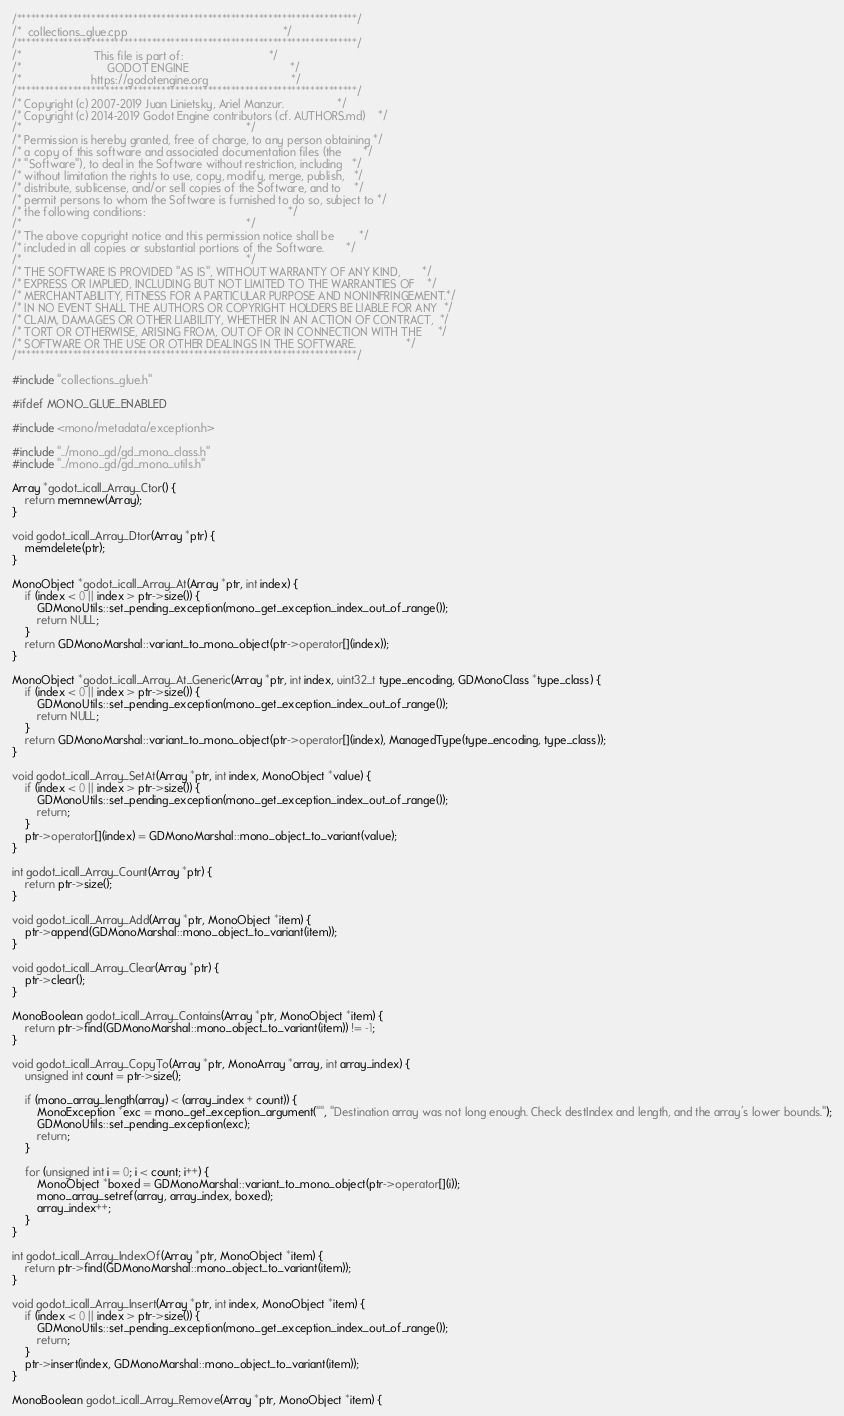Convert code to text. <code><loc_0><loc_0><loc_500><loc_500><_C++_>/*************************************************************************/
/*  collections_glue.cpp                                                 */
/*************************************************************************/
/*                       This file is part of:                           */
/*                           GODOT ENGINE                                */
/*                      https://godotengine.org                          */
/*************************************************************************/
/* Copyright (c) 2007-2019 Juan Linietsky, Ariel Manzur.                 */
/* Copyright (c) 2014-2019 Godot Engine contributors (cf. AUTHORS.md)    */
/*                                                                       */
/* Permission is hereby granted, free of charge, to any person obtaining */
/* a copy of this software and associated documentation files (the       */
/* "Software"), to deal in the Software without restriction, including   */
/* without limitation the rights to use, copy, modify, merge, publish,   */
/* distribute, sublicense, and/or sell copies of the Software, and to    */
/* permit persons to whom the Software is furnished to do so, subject to */
/* the following conditions:                                             */
/*                                                                       */
/* The above copyright notice and this permission notice shall be        */
/* included in all copies or substantial portions of the Software.       */
/*                                                                       */
/* THE SOFTWARE IS PROVIDED "AS IS", WITHOUT WARRANTY OF ANY KIND,       */
/* EXPRESS OR IMPLIED, INCLUDING BUT NOT LIMITED TO THE WARRANTIES OF    */
/* MERCHANTABILITY, FITNESS FOR A PARTICULAR PURPOSE AND NONINFRINGEMENT.*/
/* IN NO EVENT SHALL THE AUTHORS OR COPYRIGHT HOLDERS BE LIABLE FOR ANY  */
/* CLAIM, DAMAGES OR OTHER LIABILITY, WHETHER IN AN ACTION OF CONTRACT,  */
/* TORT OR OTHERWISE, ARISING FROM, OUT OF OR IN CONNECTION WITH THE     */
/* SOFTWARE OR THE USE OR OTHER DEALINGS IN THE SOFTWARE.                */
/*************************************************************************/

#include "collections_glue.h"

#ifdef MONO_GLUE_ENABLED

#include <mono/metadata/exception.h>

#include "../mono_gd/gd_mono_class.h"
#include "../mono_gd/gd_mono_utils.h"

Array *godot_icall_Array_Ctor() {
	return memnew(Array);
}

void godot_icall_Array_Dtor(Array *ptr) {
	memdelete(ptr);
}

MonoObject *godot_icall_Array_At(Array *ptr, int index) {
	if (index < 0 || index > ptr->size()) {
		GDMonoUtils::set_pending_exception(mono_get_exception_index_out_of_range());
		return NULL;
	}
	return GDMonoMarshal::variant_to_mono_object(ptr->operator[](index));
}

MonoObject *godot_icall_Array_At_Generic(Array *ptr, int index, uint32_t type_encoding, GDMonoClass *type_class) {
	if (index < 0 || index > ptr->size()) {
		GDMonoUtils::set_pending_exception(mono_get_exception_index_out_of_range());
		return NULL;
	}
	return GDMonoMarshal::variant_to_mono_object(ptr->operator[](index), ManagedType(type_encoding, type_class));
}

void godot_icall_Array_SetAt(Array *ptr, int index, MonoObject *value) {
	if (index < 0 || index > ptr->size()) {
		GDMonoUtils::set_pending_exception(mono_get_exception_index_out_of_range());
		return;
	}
	ptr->operator[](index) = GDMonoMarshal::mono_object_to_variant(value);
}

int godot_icall_Array_Count(Array *ptr) {
	return ptr->size();
}

void godot_icall_Array_Add(Array *ptr, MonoObject *item) {
	ptr->append(GDMonoMarshal::mono_object_to_variant(item));
}

void godot_icall_Array_Clear(Array *ptr) {
	ptr->clear();
}

MonoBoolean godot_icall_Array_Contains(Array *ptr, MonoObject *item) {
	return ptr->find(GDMonoMarshal::mono_object_to_variant(item)) != -1;
}

void godot_icall_Array_CopyTo(Array *ptr, MonoArray *array, int array_index) {
	unsigned int count = ptr->size();

	if (mono_array_length(array) < (array_index + count)) {
		MonoException *exc = mono_get_exception_argument("", "Destination array was not long enough. Check destIndex and length, and the array's lower bounds.");
		GDMonoUtils::set_pending_exception(exc);
		return;
	}

	for (unsigned int i = 0; i < count; i++) {
		MonoObject *boxed = GDMonoMarshal::variant_to_mono_object(ptr->operator[](i));
		mono_array_setref(array, array_index, boxed);
		array_index++;
	}
}

int godot_icall_Array_IndexOf(Array *ptr, MonoObject *item) {
	return ptr->find(GDMonoMarshal::mono_object_to_variant(item));
}

void godot_icall_Array_Insert(Array *ptr, int index, MonoObject *item) {
	if (index < 0 || index > ptr->size()) {
		GDMonoUtils::set_pending_exception(mono_get_exception_index_out_of_range());
		return;
	}
	ptr->insert(index, GDMonoMarshal::mono_object_to_variant(item));
}

MonoBoolean godot_icall_Array_Remove(Array *ptr, MonoObject *item) {</code> 